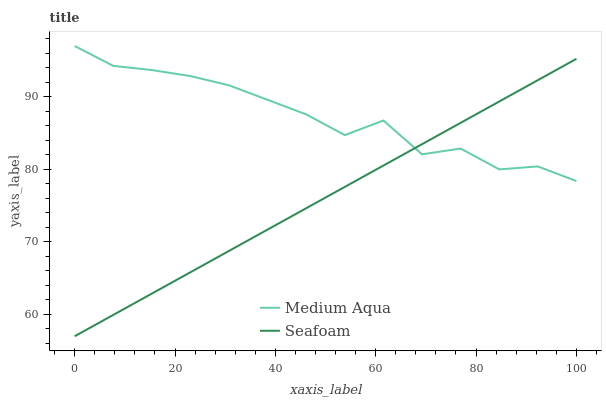Does Seafoam have the minimum area under the curve?
Answer yes or no. Yes. Does Medium Aqua have the maximum area under the curve?
Answer yes or no. Yes. Does Seafoam have the maximum area under the curve?
Answer yes or no. No. Is Seafoam the smoothest?
Answer yes or no. Yes. Is Medium Aqua the roughest?
Answer yes or no. Yes. Is Seafoam the roughest?
Answer yes or no. No. Does Medium Aqua have the highest value?
Answer yes or no. Yes. Does Seafoam have the highest value?
Answer yes or no. No. Does Seafoam intersect Medium Aqua?
Answer yes or no. Yes. Is Seafoam less than Medium Aqua?
Answer yes or no. No. Is Seafoam greater than Medium Aqua?
Answer yes or no. No. 